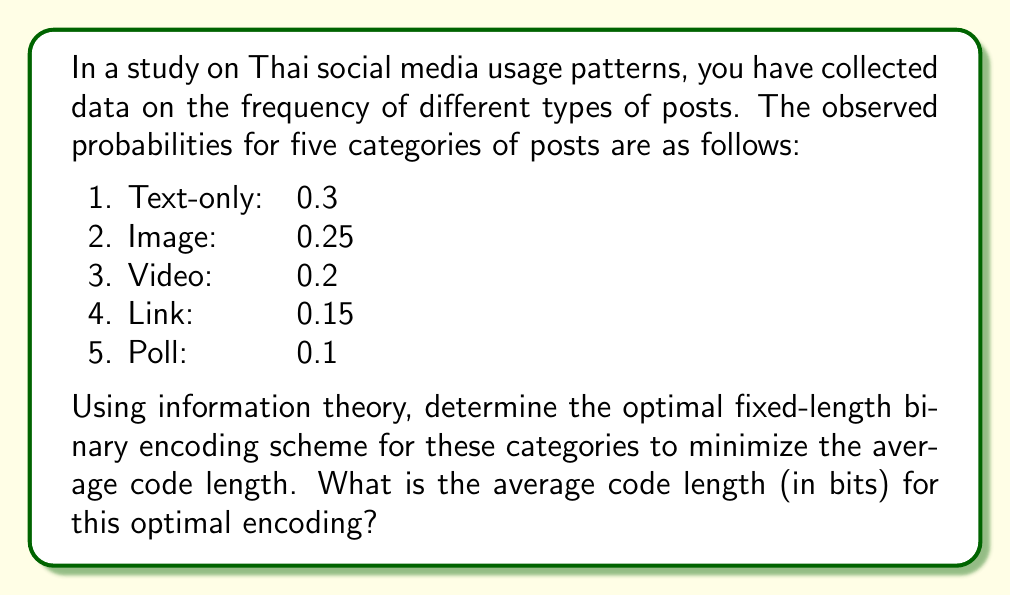Show me your answer to this math problem. To solve this problem, we'll use concepts from information theory to determine the optimal fixed-length binary encoding scheme. Here's a step-by-step approach:

1. First, we need to determine the minimum number of bits required to encode all categories. With 5 categories, we need at least $\lceil \log_2(5) \rceil = 3$ bits.

2. Now, we'll assign a unique 3-bit code to each category:
   - Text-only: 000
   - Image: 001
   - Video: 010
   - Link: 011
   - Poll: 100

3. To calculate the average code length, we use the formula:

   $$L = \sum_{i=1}^{n} p_i l_i$$

   Where:
   - $L$ is the average code length
   - $p_i$ is the probability of each category
   - $l_i$ is the length of the code for each category (in this case, always 3)

4. Substituting the values:

   $$\begin{align}
   L &= (0.3 \times 3) + (0.25 \times 3) + (0.2 \times 3) + (0.15 \times 3) + (0.1 \times 3) \\
   &= 0.9 + 0.75 + 0.6 + 0.45 + 0.3 \\
   &= 3 \text{ bits}
   \end{align}$$

5. We can verify that this is optimal for a fixed-length encoding by calculating the entropy of the source:

   $$H = -\sum_{i=1}^{n} p_i \log_2(p_i)$$

   $$\begin{align}
   H &= -[0.3 \log_2(0.3) + 0.25 \log_2(0.25) + 0.2 \log_2(0.2) + 0.15 \log_2(0.15) + 0.1 \log_2(0.1)] \\
   &\approx 2.19 \text{ bits}
   \end{align}$$

   The entropy is less than 3, confirming that our 3-bit encoding is the best we can do with a fixed-length scheme.
Answer: The average code length for the optimal fixed-length binary encoding scheme is 3 bits. 